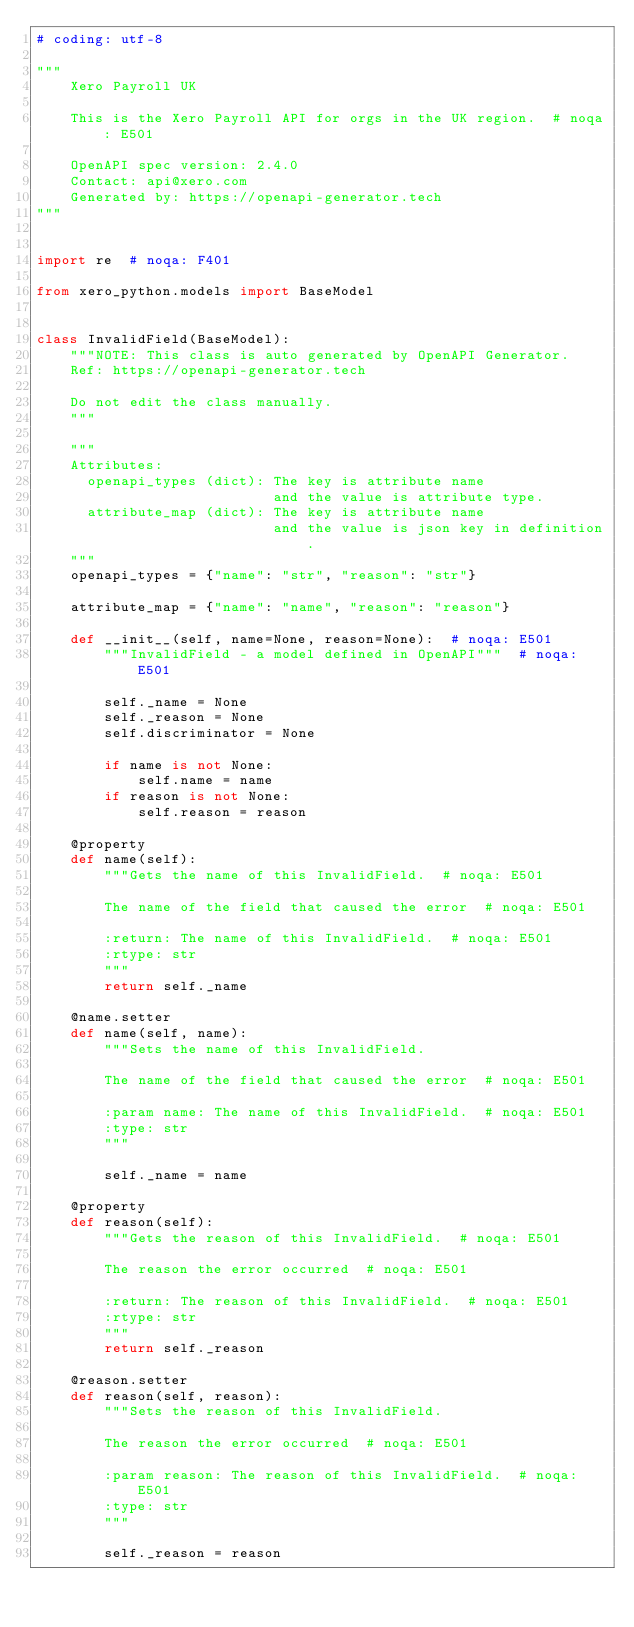Convert code to text. <code><loc_0><loc_0><loc_500><loc_500><_Python_># coding: utf-8

"""
    Xero Payroll UK

    This is the Xero Payroll API for orgs in the UK region.  # noqa: E501

    OpenAPI spec version: 2.4.0
    Contact: api@xero.com
    Generated by: https://openapi-generator.tech
"""


import re  # noqa: F401

from xero_python.models import BaseModel


class InvalidField(BaseModel):
    """NOTE: This class is auto generated by OpenAPI Generator.
    Ref: https://openapi-generator.tech

    Do not edit the class manually.
    """

    """
    Attributes:
      openapi_types (dict): The key is attribute name
                            and the value is attribute type.
      attribute_map (dict): The key is attribute name
                            and the value is json key in definition.
    """
    openapi_types = {"name": "str", "reason": "str"}

    attribute_map = {"name": "name", "reason": "reason"}

    def __init__(self, name=None, reason=None):  # noqa: E501
        """InvalidField - a model defined in OpenAPI"""  # noqa: E501

        self._name = None
        self._reason = None
        self.discriminator = None

        if name is not None:
            self.name = name
        if reason is not None:
            self.reason = reason

    @property
    def name(self):
        """Gets the name of this InvalidField.  # noqa: E501

        The name of the field that caused the error  # noqa: E501

        :return: The name of this InvalidField.  # noqa: E501
        :rtype: str
        """
        return self._name

    @name.setter
    def name(self, name):
        """Sets the name of this InvalidField.

        The name of the field that caused the error  # noqa: E501

        :param name: The name of this InvalidField.  # noqa: E501
        :type: str
        """

        self._name = name

    @property
    def reason(self):
        """Gets the reason of this InvalidField.  # noqa: E501

        The reason the error occurred  # noqa: E501

        :return: The reason of this InvalidField.  # noqa: E501
        :rtype: str
        """
        return self._reason

    @reason.setter
    def reason(self, reason):
        """Sets the reason of this InvalidField.

        The reason the error occurred  # noqa: E501

        :param reason: The reason of this InvalidField.  # noqa: E501
        :type: str
        """

        self._reason = reason
</code> 